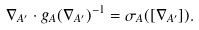Convert formula to latex. <formula><loc_0><loc_0><loc_500><loc_500>\nabla _ { A ^ { \prime } } \cdot g _ { A } ( \nabla _ { A ^ { \prime } } ) ^ { - 1 } = \sigma _ { A } ( [ \nabla _ { A ^ { \prime } } ] ) .</formula> 